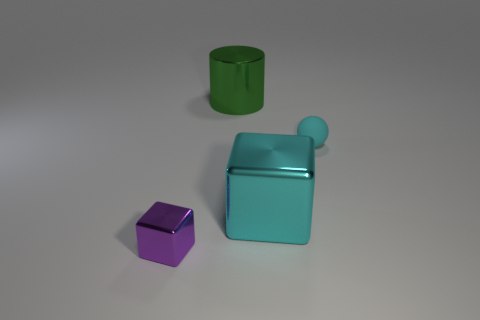How many shiny blocks are the same size as the green thing?
Give a very brief answer. 1. How many other things are the same color as the big cylinder?
Provide a short and direct response. 0. Is there anything else that has the same size as the green shiny object?
Your answer should be very brief. Yes. There is a large thing in front of the rubber thing; is it the same shape as the tiny thing right of the purple thing?
Provide a short and direct response. No. What is the shape of the other thing that is the same size as the purple metallic thing?
Keep it short and to the point. Sphere. Is the number of small metallic blocks on the right side of the large cyan metallic thing the same as the number of small matte spheres that are on the left side of the large shiny cylinder?
Offer a very short reply. Yes. Is there anything else that has the same shape as the green shiny object?
Your response must be concise. No. Is the big cylinder to the right of the purple thing made of the same material as the cyan block?
Your response must be concise. Yes. There is a cyan sphere that is the same size as the purple shiny block; what is its material?
Your response must be concise. Rubber. How many other things are there of the same material as the big green cylinder?
Offer a very short reply. 2. 